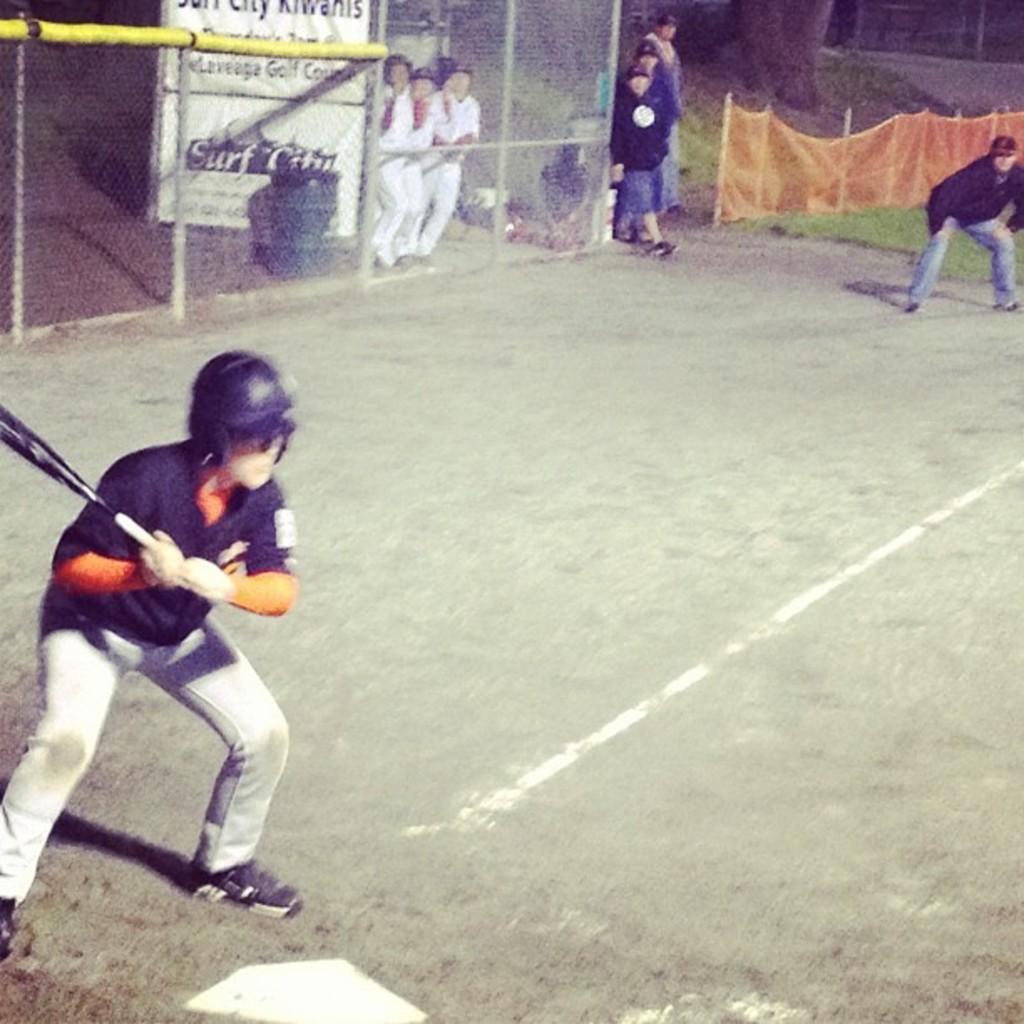What city is seen on the poster in the back?
Provide a short and direct response. Surf city. Which club sponsors the team?
Make the answer very short. Surf city. 